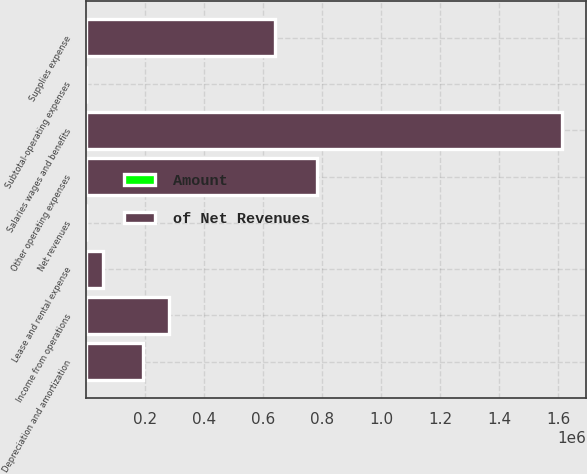Convert chart to OTSL. <chart><loc_0><loc_0><loc_500><loc_500><stacked_bar_chart><ecel><fcel>Net revenues<fcel>Salaries wages and benefits<fcel>Other operating expenses<fcel>Supplies expense<fcel>Depreciation and amortization<fcel>Lease and rental expense<fcel>Subtotal-operating expenses<fcel>Income from operations<nl><fcel>of Net Revenues<fcel>96.05<fcel>1.61428e+06<fcel>781812<fcel>641078<fcel>191274<fcel>57384<fcel>96.05<fcel>281001<nl><fcel>Amount<fcel>100<fcel>45.3<fcel>21.9<fcel>18<fcel>5.4<fcel>1.6<fcel>92.1<fcel>7.9<nl></chart> 